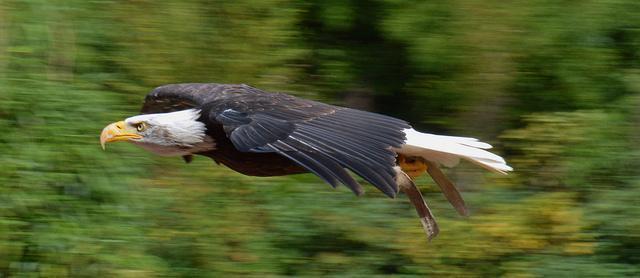How many person in the image is wearing black color t-shirt?
Give a very brief answer. 0. 